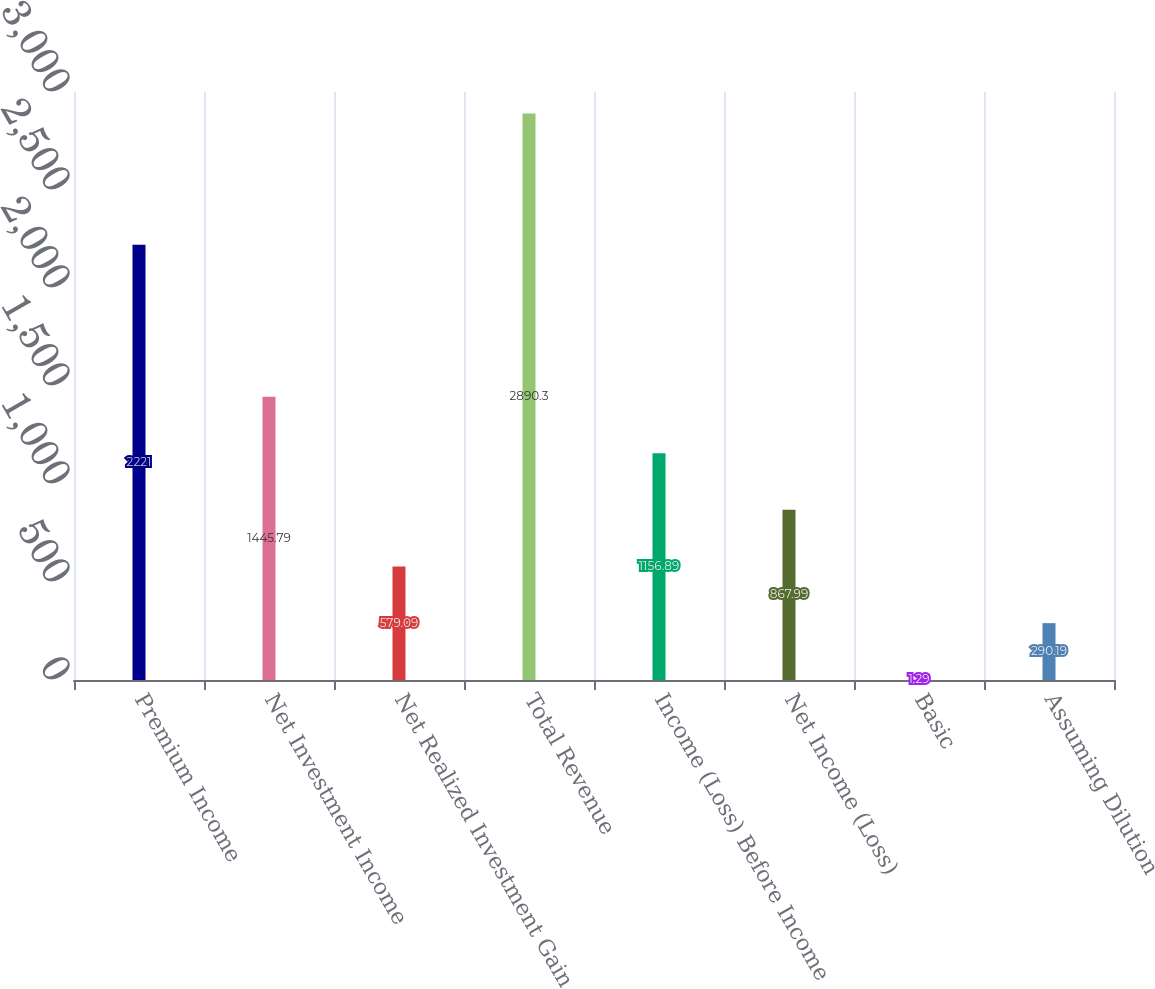Convert chart to OTSL. <chart><loc_0><loc_0><loc_500><loc_500><bar_chart><fcel>Premium Income<fcel>Net Investment Income<fcel>Net Realized Investment Gain<fcel>Total Revenue<fcel>Income (Loss) Before Income<fcel>Net Income (Loss)<fcel>Basic<fcel>Assuming Dilution<nl><fcel>2221<fcel>1445.79<fcel>579.09<fcel>2890.3<fcel>1156.89<fcel>867.99<fcel>1.29<fcel>290.19<nl></chart> 